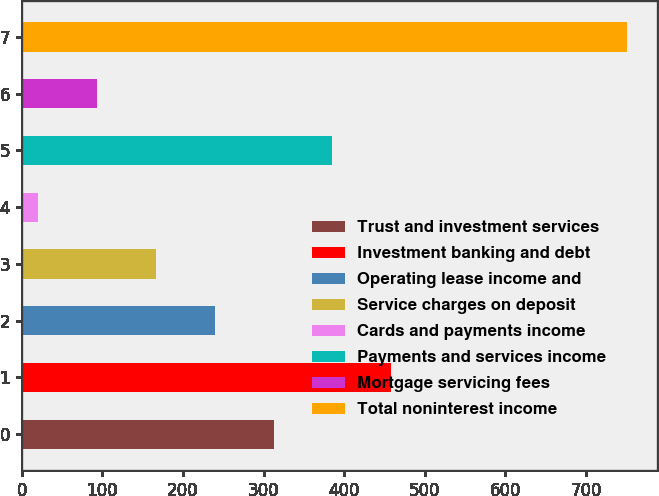Convert chart. <chart><loc_0><loc_0><loc_500><loc_500><bar_chart><fcel>Trust and investment services<fcel>Investment banking and debt<fcel>Operating lease income and<fcel>Service charges on deposit<fcel>Cards and payments income<fcel>Payments and services income<fcel>Mortgage servicing fees<fcel>Total noninterest income<nl><fcel>312.4<fcel>458.6<fcel>239.3<fcel>166.2<fcel>20<fcel>385.5<fcel>93.1<fcel>751<nl></chart> 